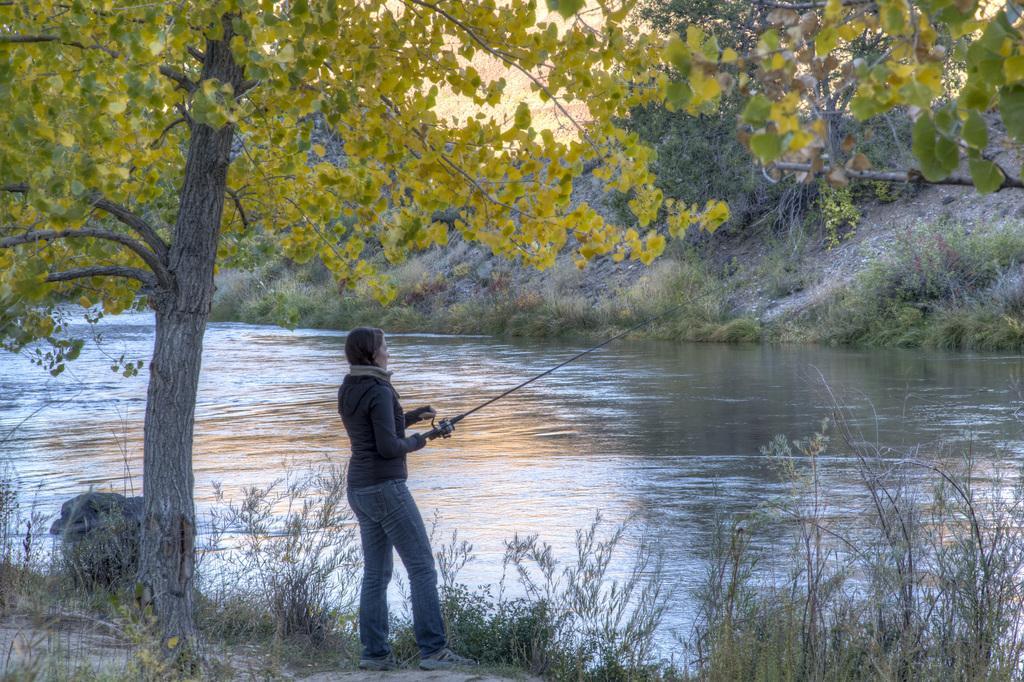Please provide a concise description of this image. In this image, we can see a woman is holding a stick and standing. At the bottom, we can see few plants, grass. In the middle, there is a river. Here we can see so many trees. 